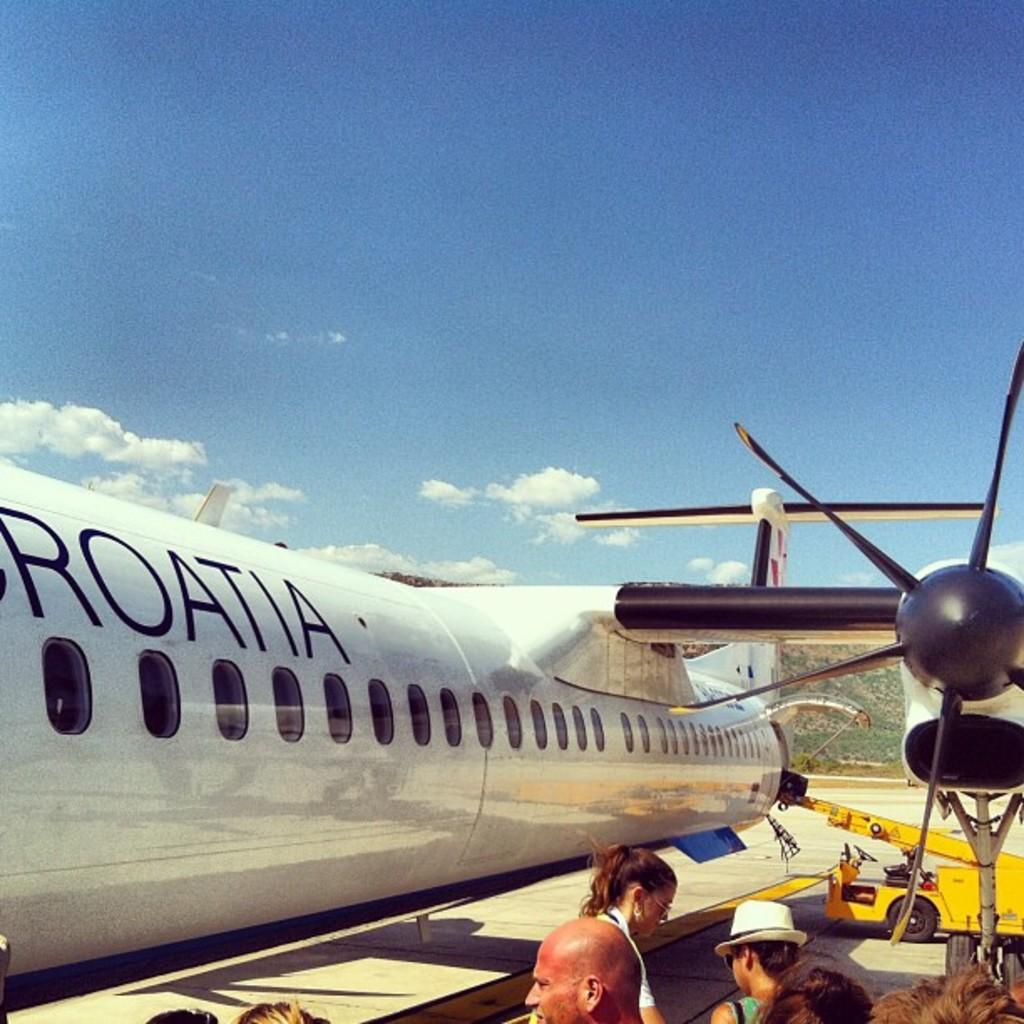<image>
Give a short and clear explanation of the subsequent image. A group of people stand beside an aeroplane with Croatia on its side. 